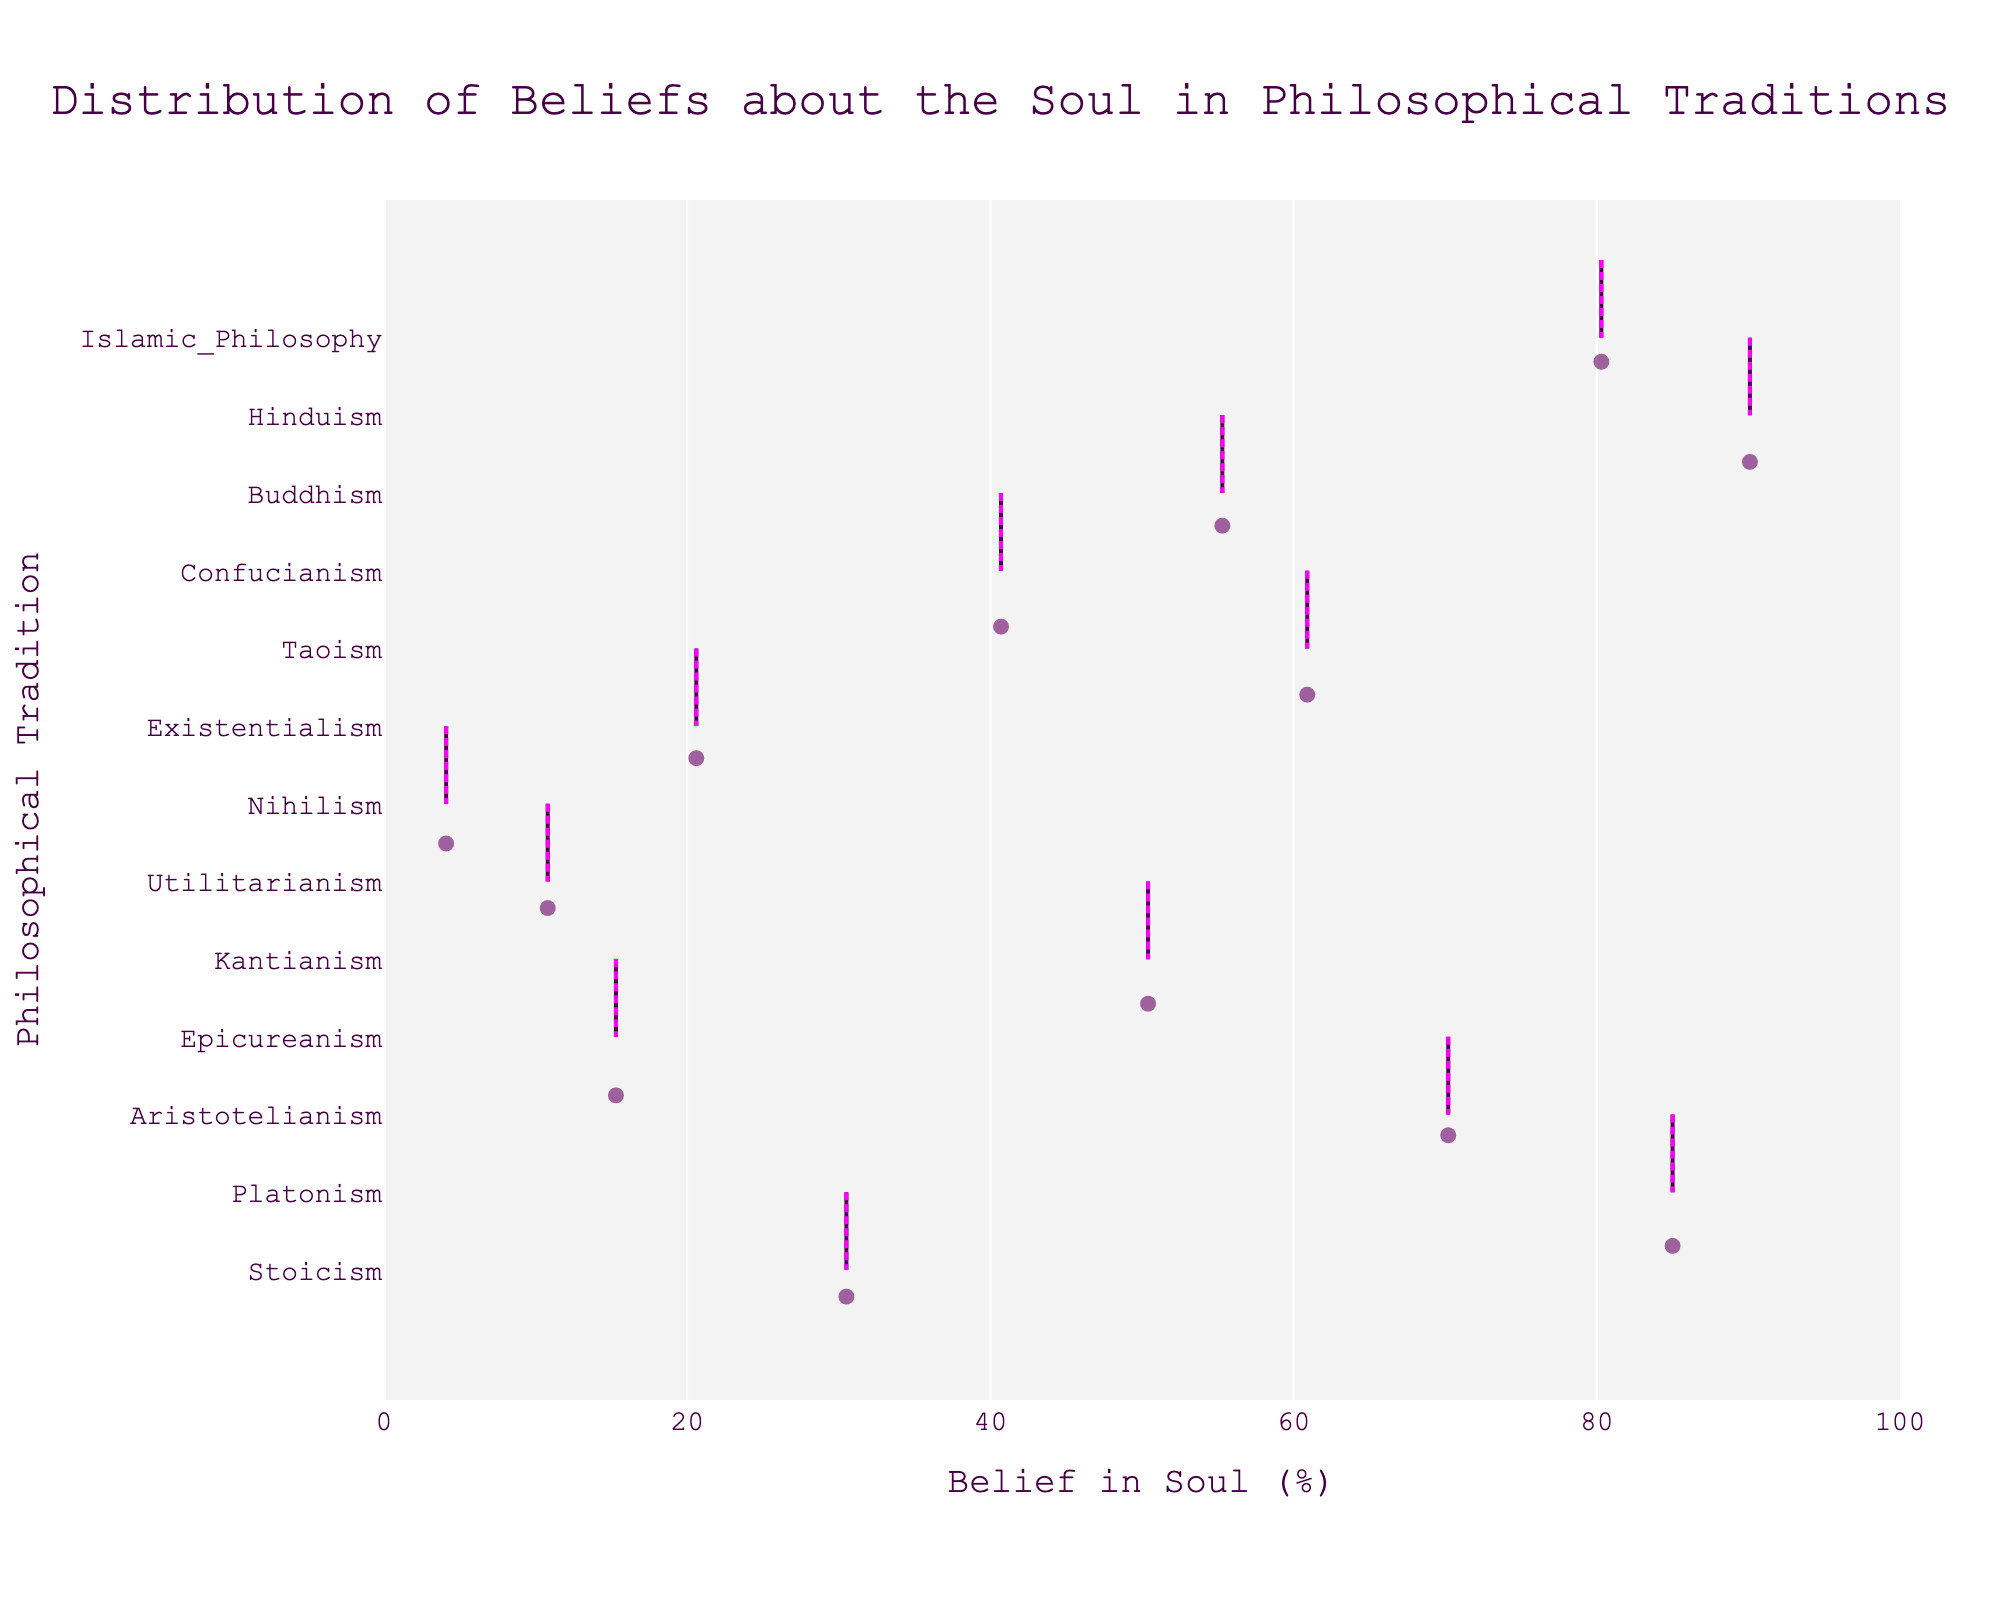What is the title of the plot? The title of the plot is located at the top and often provides a summary of what the chart represents. In this case, the title is "Distribution of Beliefs about the Soul in Philosophical Traditions".
Answer: Distribution of Beliefs about the Soul in Philosophical Traditions What is the range of belief in the soul values shown in the plot? The range of values can be observed on the X-axis, which lists the percentages. The values start from 0% and go up to 100%.
Answer: 0% to 100% Which philosophical tradition exhibits the highest belief in the soul? By visually scanning the plot, the tradition with the highest value on the X-axis indicates the highest belief. Hinduism reaches the highest point at 90.1%.
Answer: Hinduism Compare the belief in the soul between Platonism and Epicureanism. To compare the values, look at the points on the X-axis for both traditions. Platonism shows a belief of 85.0% while Epicureanism shows 15.3%. Thus, Platonism has a significantly higher belief in the soul.
Answer: Platonism is higher What is the average belief in the soul among the given philosophical traditions? To find the average, sum all the belief percentages and divide by the number of traditions: (30.5 + 85.0 + 70.2 + 15.3 + 50.4 + 10.8 + 4.1 + 20.6 + 60.9 + 40.7 + 55.3 + 90.1 + 80.3) / 13 = 49.9%.
Answer: 49.9% Explain the significance of the pink mean line in the violin plot. The pink mean line inside the violin plot indicates the average or mean belief in the soul for each tradition, helping viewers quickly identify central tendency amidst the distribution.
Answer: Indicates the mean Which tradition has the lowest belief in the soul, and what is its value? By observing the X-axis values, Nihilism has the lowest belief percentage at 4.1%.
Answer: Nihilism, 4.1% How does Stoicism’s belief in the soul compare to Existentialism’s belief? Compare the positions of Stoicism (30.5%) and Existentialism (20.6%) on the X-axis. Stoicism has a higher belief in the soul than Existentialism.
Answer: Stoicism is higher What percentage of belief does Buddhism have in the soul, and how does it compare to Confucianism? Buddhism has a belief percentage of 55.3%, visible on the plot. Confucianism's belief is 40.7%. Therefore, Buddhism has a higher belief percentage compared to Confucianism.
Answer: Buddhism 55.3%, higher than Confucianism Based on the figure, identify the philosophical traditions with a belief in the soul above 70%. By scanning the X-axis values above 70%, Platonism (85.0%), Aristotelianism (70.2%), Hinduism (90.1%), and Islamic Philosophy (80.3%) have beliefs in the soul above 70%.
Answer: Platonism, Aristotelianism, Hinduism, Islamic Philosophy 